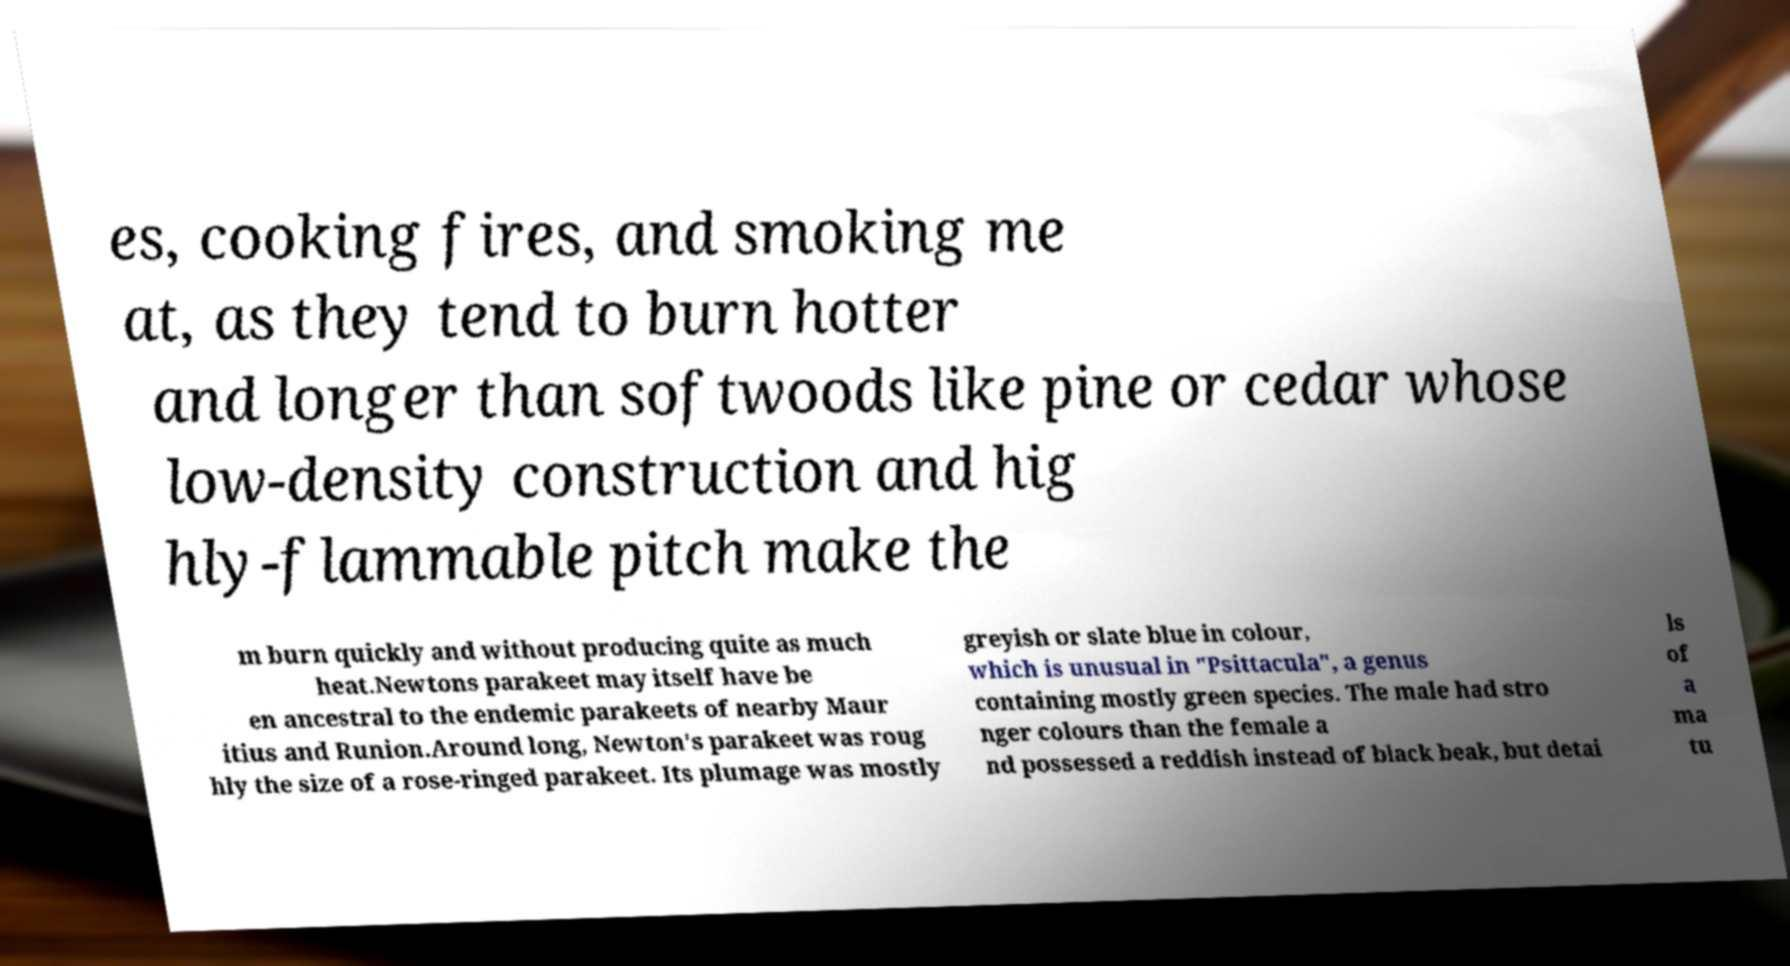Could you assist in decoding the text presented in this image and type it out clearly? es, cooking fires, and smoking me at, as they tend to burn hotter and longer than softwoods like pine or cedar whose low-density construction and hig hly-flammable pitch make the m burn quickly and without producing quite as much heat.Newtons parakeet may itself have be en ancestral to the endemic parakeets of nearby Maur itius and Runion.Around long, Newton's parakeet was roug hly the size of a rose-ringed parakeet. Its plumage was mostly greyish or slate blue in colour, which is unusual in "Psittacula", a genus containing mostly green species. The male had stro nger colours than the female a nd possessed a reddish instead of black beak, but detai ls of a ma tu 